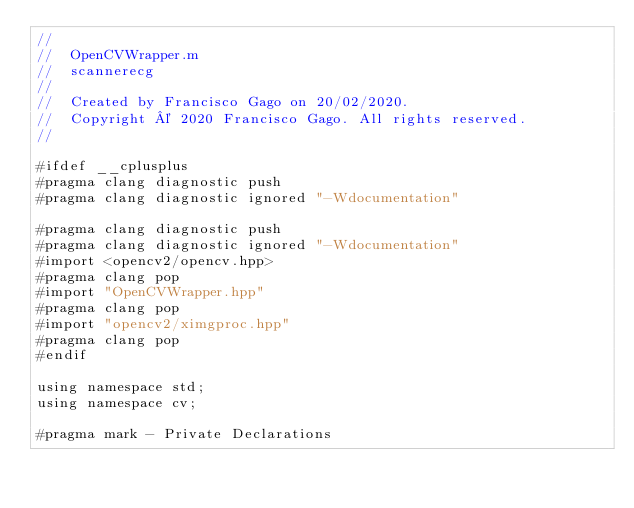<code> <loc_0><loc_0><loc_500><loc_500><_ObjectiveC_>//
//  OpenCVWrapper.m
//  scannerecg
//
//  Created by Francisco Gago on 20/02/2020.
//  Copyright © 2020 Francisco Gago. All rights reserved.
//

#ifdef __cplusplus
#pragma clang diagnostic push
#pragma clang diagnostic ignored "-Wdocumentation"

#pragma clang diagnostic push
#pragma clang diagnostic ignored "-Wdocumentation"
#import <opencv2/opencv.hpp>
#pragma clang pop
#import "OpenCVWrapper.hpp"
#pragma clang pop
#import "opencv2/ximgproc.hpp"
#pragma clang pop
#endif

using namespace std;
using namespace cv;

#pragma mark - Private Declarations
</code> 